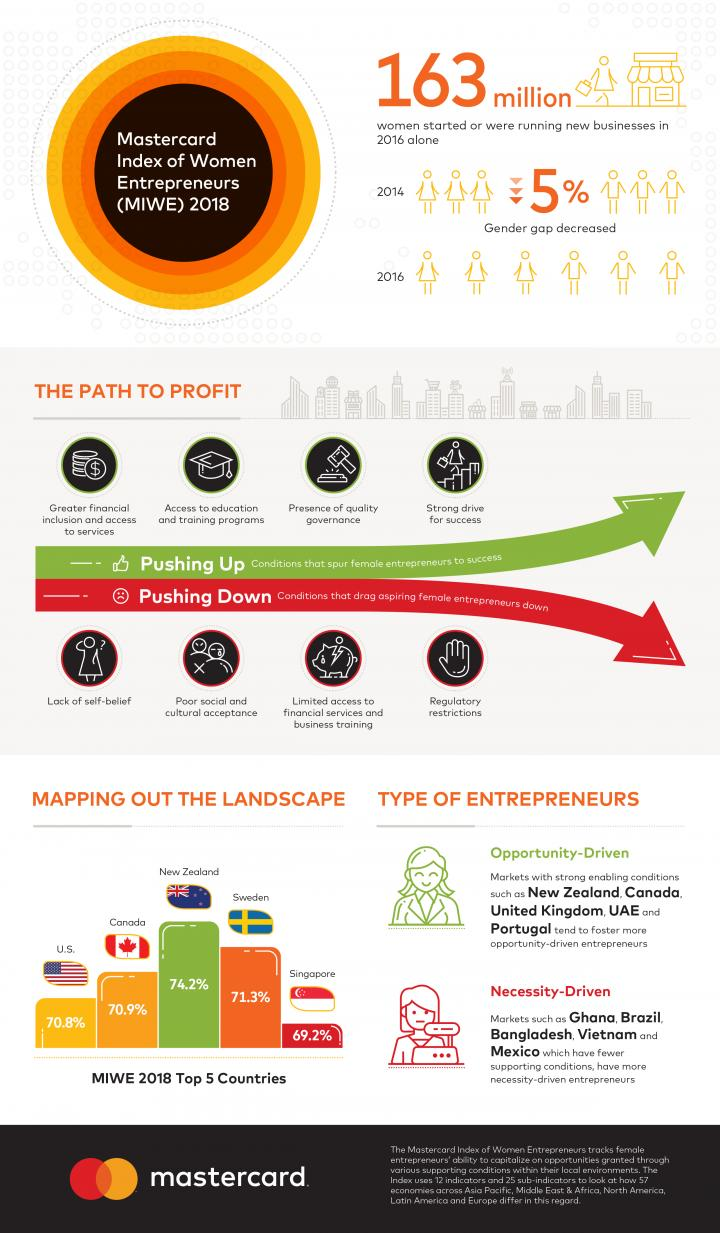List a handful of essential elements in this visual. There are two main types of entrepreneurs: opportunity-driven and necessity-driven. Opportunity-driven entrepreneurs are motivated by the potential for growth and profit in a particular market, while necessity-driven entrepreneurs are driven by a need or desire to address a specific problem or meet a specific need in the market. According to the MIWE 2018 report, New Zealand has the highest percentage of women entrepreneurs among the top countries. According to the MIWE 2018, 70.9% of women entrepreneurs in Canada are present. According to the MIWE 2018 ranking, Sweden has the second-highest percentage of women entrepreneurs among the top countries. 